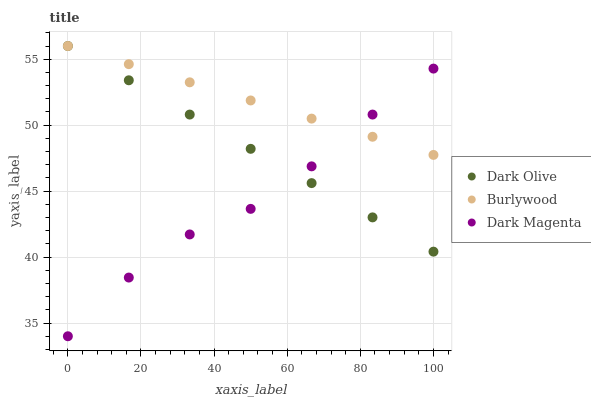Does Dark Magenta have the minimum area under the curve?
Answer yes or no. Yes. Does Burlywood have the maximum area under the curve?
Answer yes or no. Yes. Does Dark Olive have the minimum area under the curve?
Answer yes or no. No. Does Dark Olive have the maximum area under the curve?
Answer yes or no. No. Is Dark Olive the smoothest?
Answer yes or no. Yes. Is Dark Magenta the roughest?
Answer yes or no. Yes. Is Dark Magenta the smoothest?
Answer yes or no. No. Is Dark Olive the roughest?
Answer yes or no. No. Does Dark Magenta have the lowest value?
Answer yes or no. Yes. Does Dark Olive have the lowest value?
Answer yes or no. No. Does Dark Olive have the highest value?
Answer yes or no. Yes. Does Dark Magenta have the highest value?
Answer yes or no. No. Does Dark Olive intersect Burlywood?
Answer yes or no. Yes. Is Dark Olive less than Burlywood?
Answer yes or no. No. Is Dark Olive greater than Burlywood?
Answer yes or no. No. 